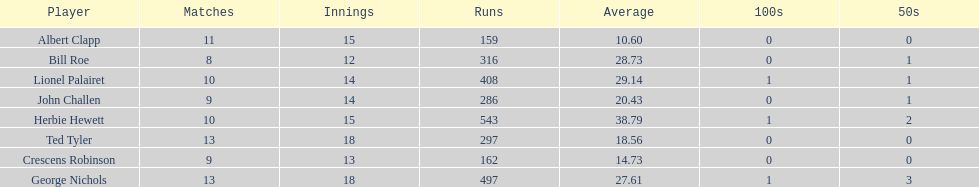What is the least about of runs anyone has? 159. 